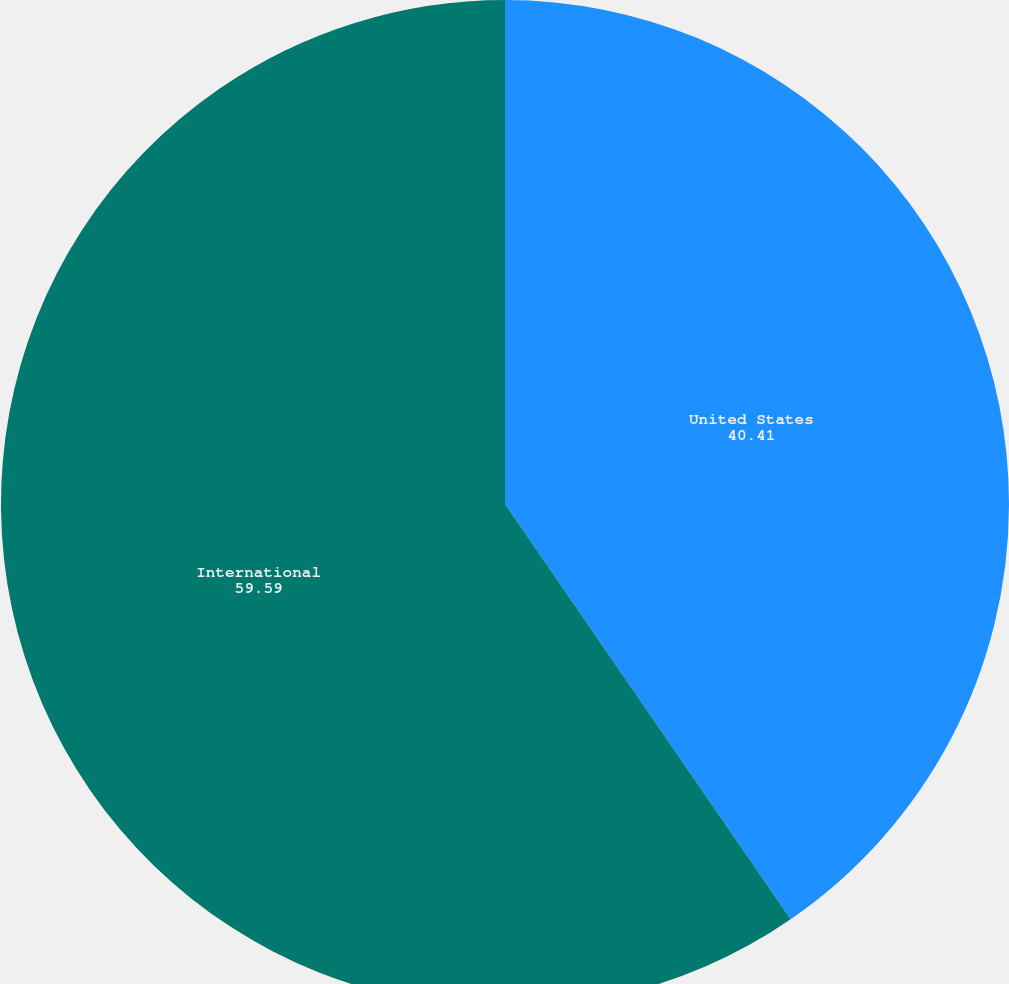<chart> <loc_0><loc_0><loc_500><loc_500><pie_chart><fcel>United States<fcel>International<nl><fcel>40.41%<fcel>59.59%<nl></chart> 